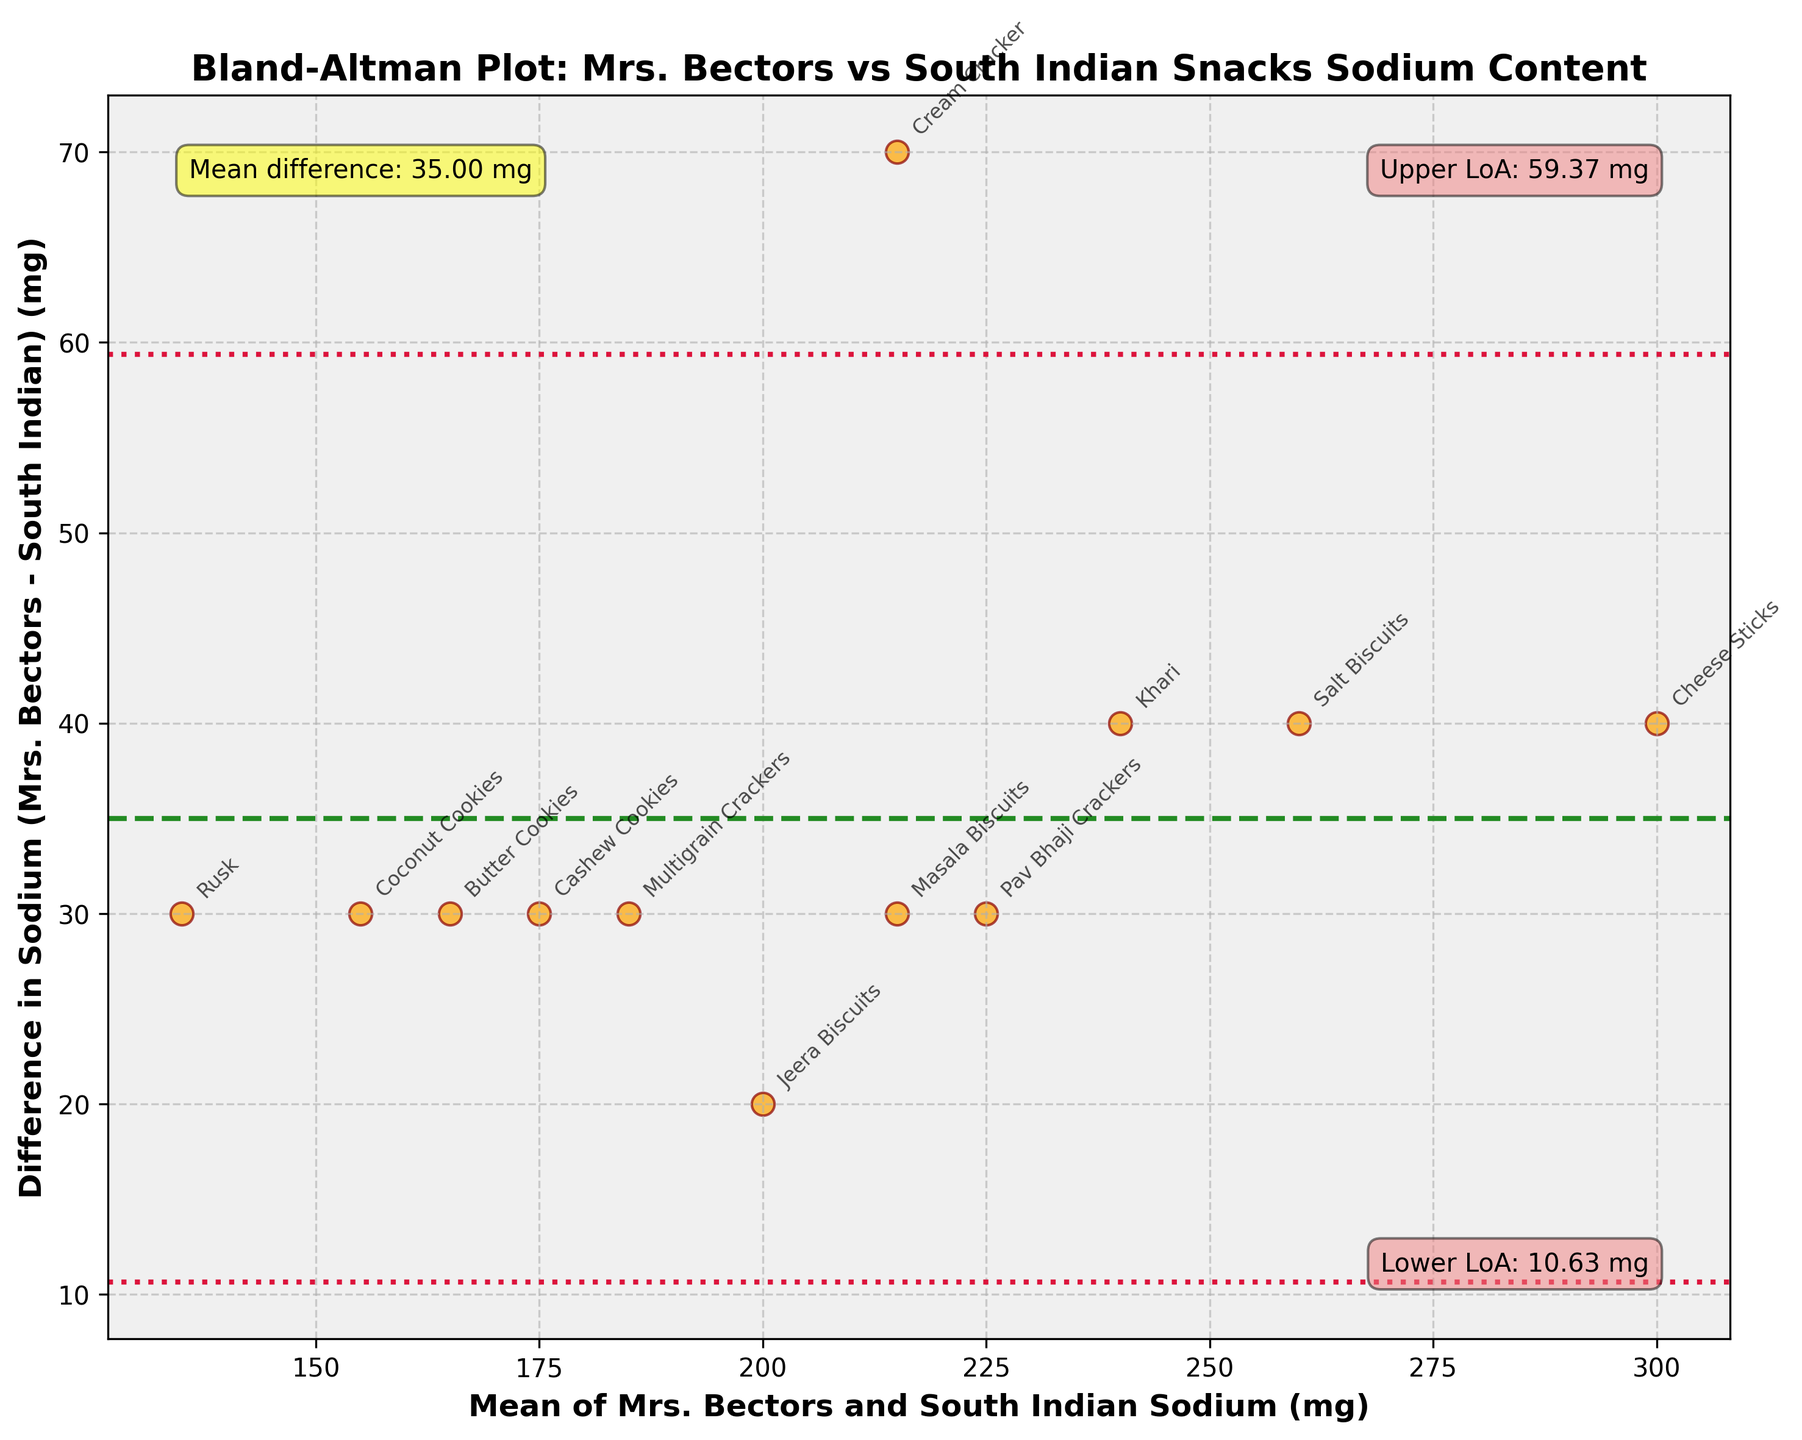What's the title of the plot? The title is displayed at the top of the plot. It provides a summary of what the figure represents.
Answer: Bland-Altman Plot: Mrs. Bectors vs South Indian Snacks Sodium Content How many snacks are compared in the plot? Each point in the scatter plot represents a snack, and we can count these points.
Answer: 12 What does the x-axis represent? The x-axis label provides the information of the variable plotted along this axis.
Answer: Mean of Mrs. Bectors and South Indian Sodium (mg) What does the y-axis represent? The y-axis label gives the variable plotted along this axis.
Answer: Difference in Sodium (Mrs. Bectors - South Indian) (mg) What is the mean difference in the sodium content between Mrs. Bectors and South Indian snacks? A horizontal line representing the mean difference is labeled within the plot with its numerical value.
Answer: 42.5 mg What do the red dashed lines represent? The red dashed lines are important in a Bland-Altman plot as they indicate the limits of agreement, which are annotated within the figure.
Answer: Upper and Lower Limits of Agreement Which snack has the largest positive difference in sodium content? By observing the highest point on the y-axis, we can identify the snack with the largest positive difference.
Answer: Cheese Sticks What is the mean sodium content for the Khari snack? Calculate the mean from the given sodium contents for Khari (Mrs. Bectors and South Indian).
Answer: 240 mg How much higher is the sodium content of Mrs. Bectors Masala Biscuits compared to South Indian Masala Biscuits? Look at the y-axis value corresponding to the Masala Biscuits data point.
Answer: 30 mg Which snack shows the smallest difference in sodium content between Mrs. Bectors and South Indian versions? Find the point closest to the x-axis on the plot, representing the smallest difference.
Answer: Jeera Biscuits 